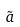Convert formula to latex. <formula><loc_0><loc_0><loc_500><loc_500>\tilde { a }</formula> 